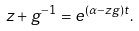<formula> <loc_0><loc_0><loc_500><loc_500>z + g ^ { - 1 } = e ^ { ( \alpha - z g ) t } .</formula> 